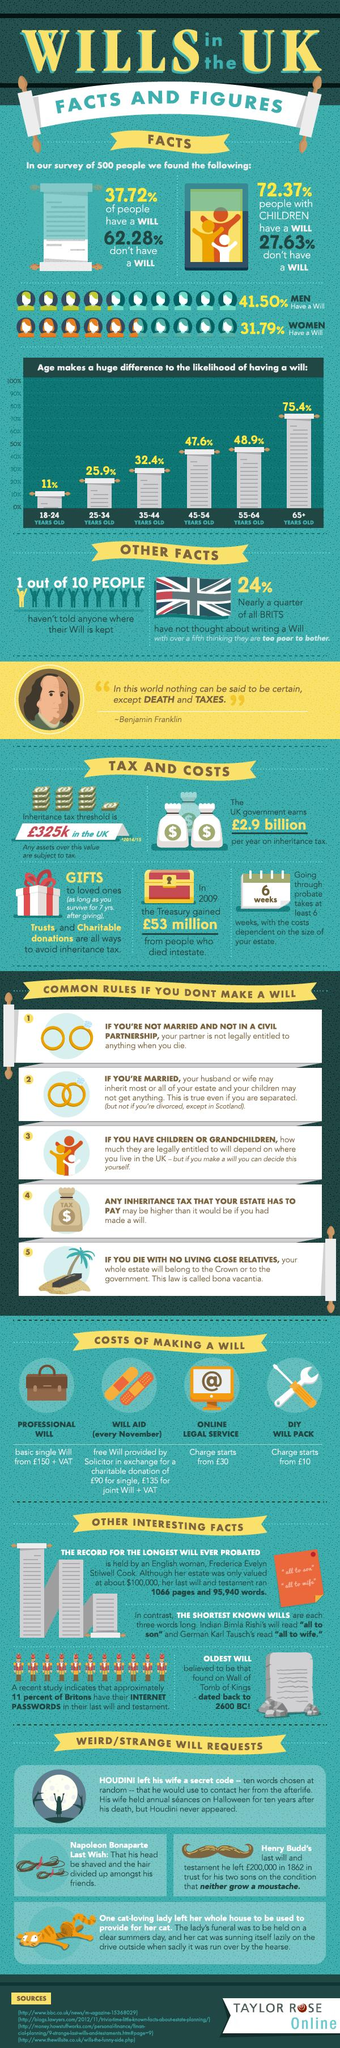Indicate a few pertinent items in this graphic. The wills, each consisting of only three words, read 'all to son' and 'all to wife'. The percentage difference between men and women writing a will is 9.71%. 